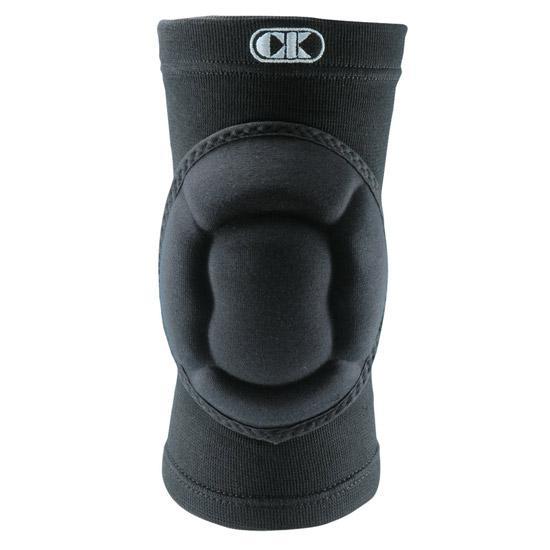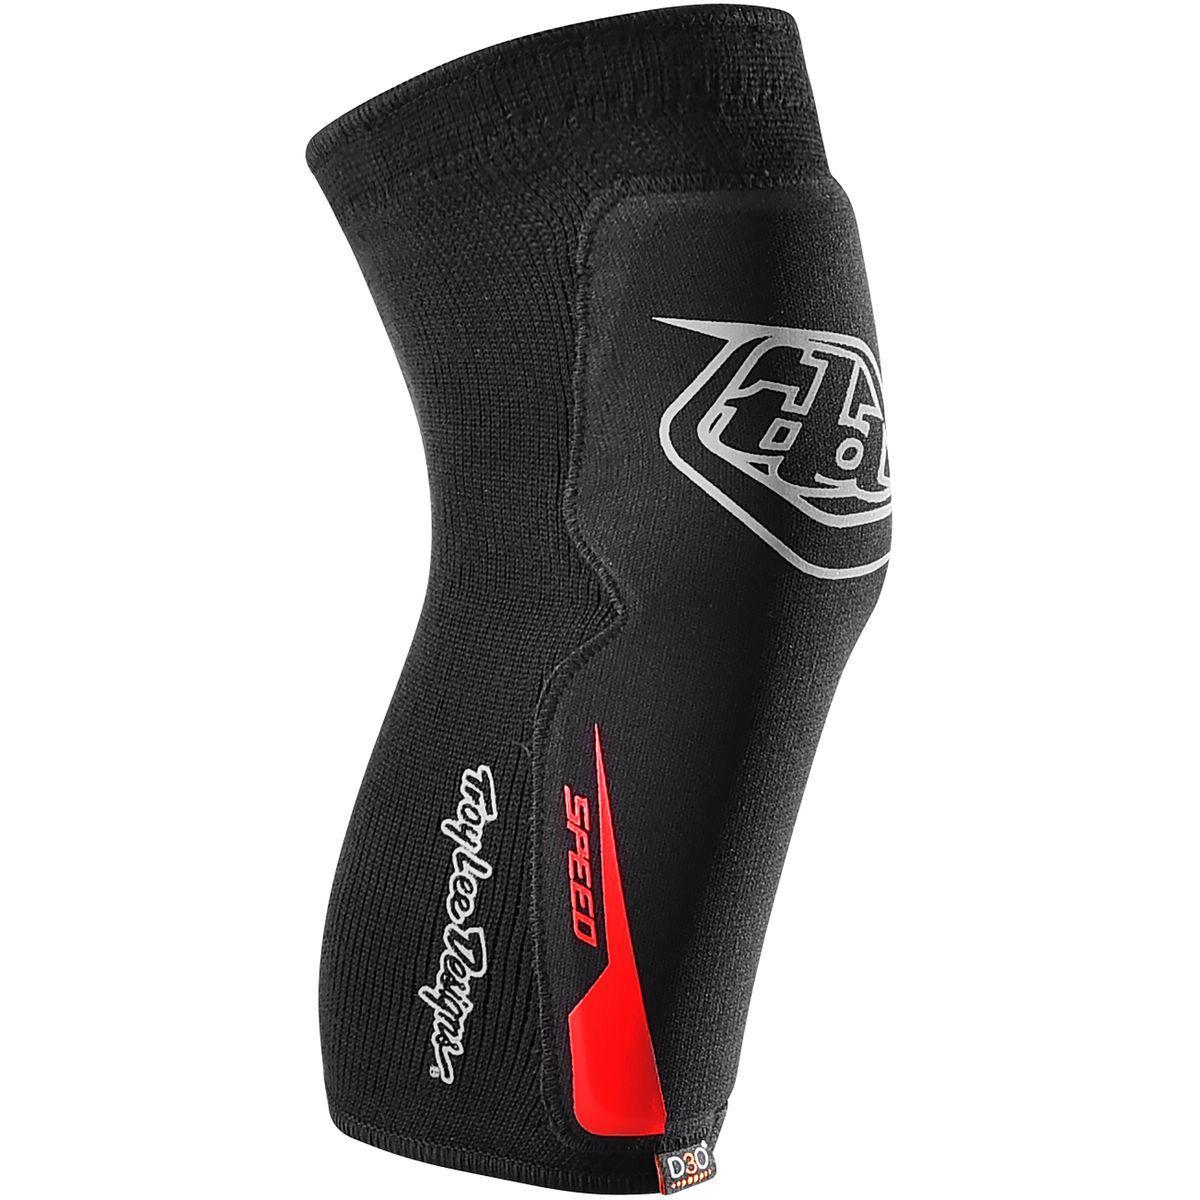The first image is the image on the left, the second image is the image on the right. Analyze the images presented: Is the assertion "The knee pad is turned to the right in the image on the right." valid? Answer yes or no. Yes. 